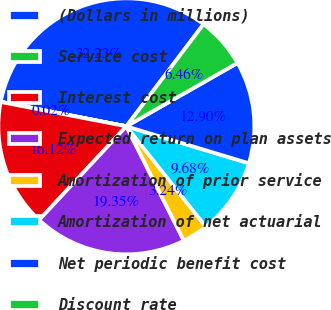Convert chart. <chart><loc_0><loc_0><loc_500><loc_500><pie_chart><fcel>(Dollars in millions)<fcel>Service cost<fcel>Interest cost<fcel>Expected return on plan assets<fcel>Amortization of prior service<fcel>Amortization of net actuarial<fcel>Net periodic benefit cost<fcel>Discount rate<nl><fcel>32.23%<fcel>0.02%<fcel>16.12%<fcel>19.35%<fcel>3.24%<fcel>9.68%<fcel>12.9%<fcel>6.46%<nl></chart> 